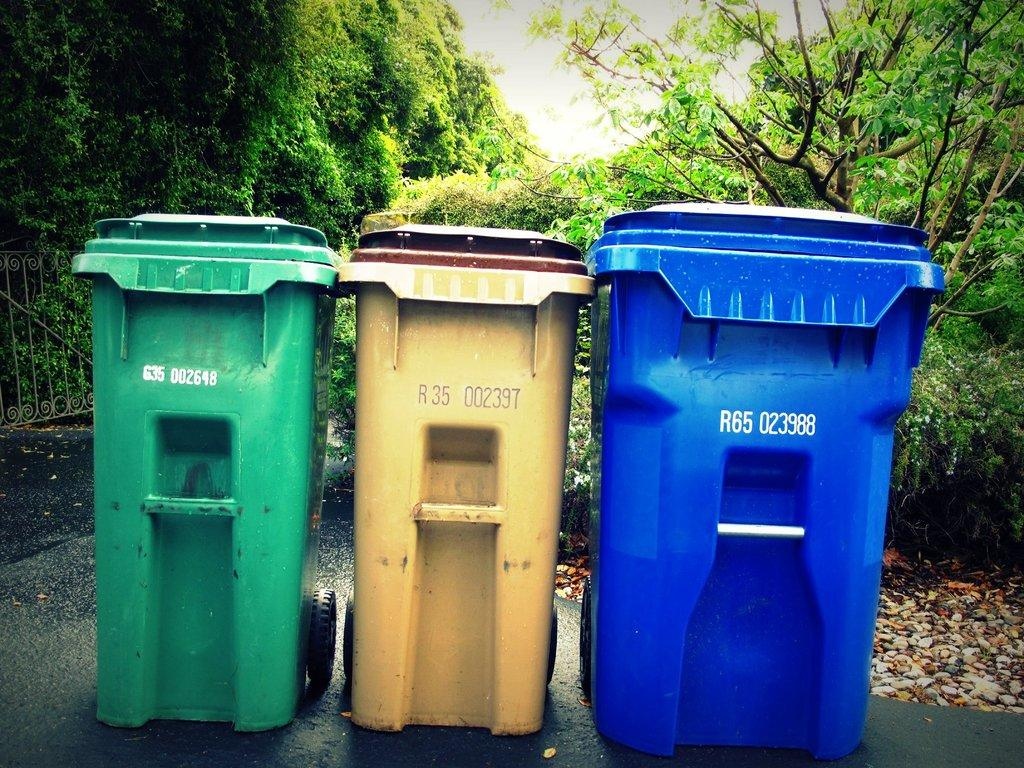<image>
Write a terse but informative summary of the picture. Three serialized garbage bins, numerical 9-character serial numbers IDs of each are showing 